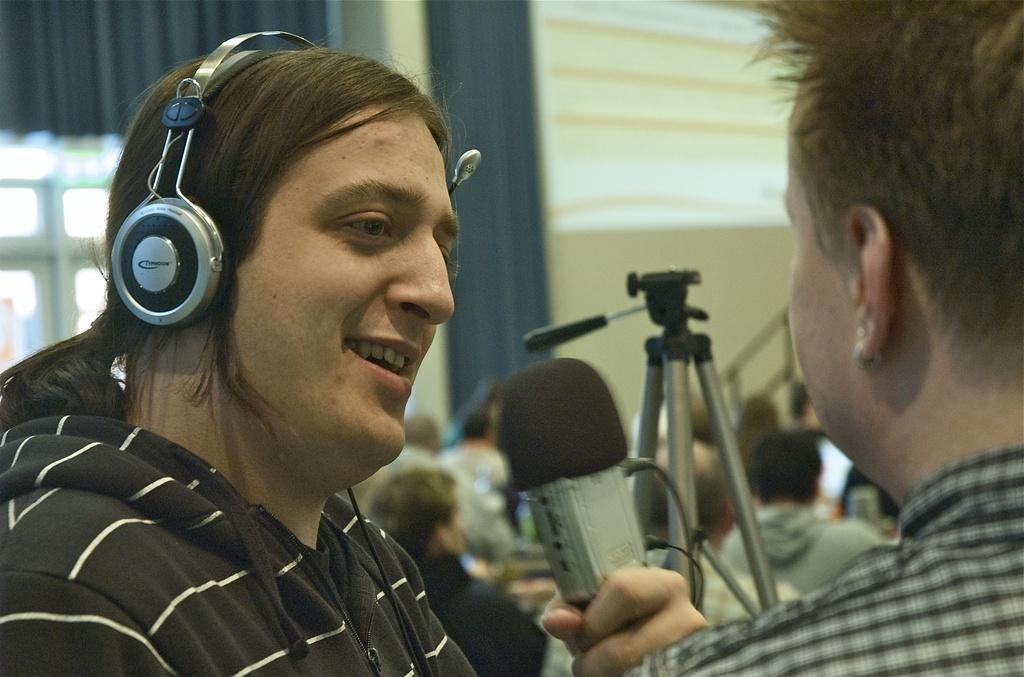How many people are present in the image? There are two people in the image. What is one person doing in the image? One person is holding something. What can be seen in the background of the image? There is a stand, a curtain, a window, and a wall in the image. Are there any other people visible in the image? Yes, there are a few other people in the image. What type of stove is visible in the image? There is no stove present in the image. How does the adjustment of the curtain affect the lighting in the image? The image does not show any adjustment of the curtain, so we cannot determine how it might affect the lighting. 